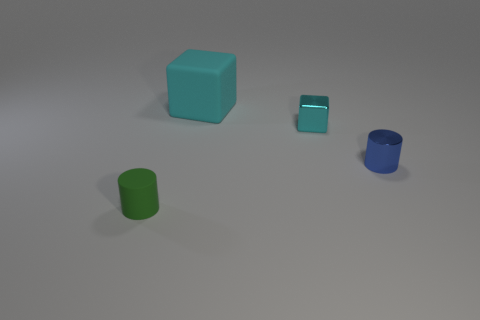Add 4 metal cubes. How many objects exist? 8 Subtract all green cylinders. How many cylinders are left? 1 Subtract all purple cylinders. Subtract all green blocks. How many cylinders are left? 2 Subtract all blue objects. Subtract all small green objects. How many objects are left? 2 Add 4 tiny cyan metallic cubes. How many tiny cyan metallic cubes are left? 5 Add 3 cyan things. How many cyan things exist? 5 Subtract 0 brown cubes. How many objects are left? 4 